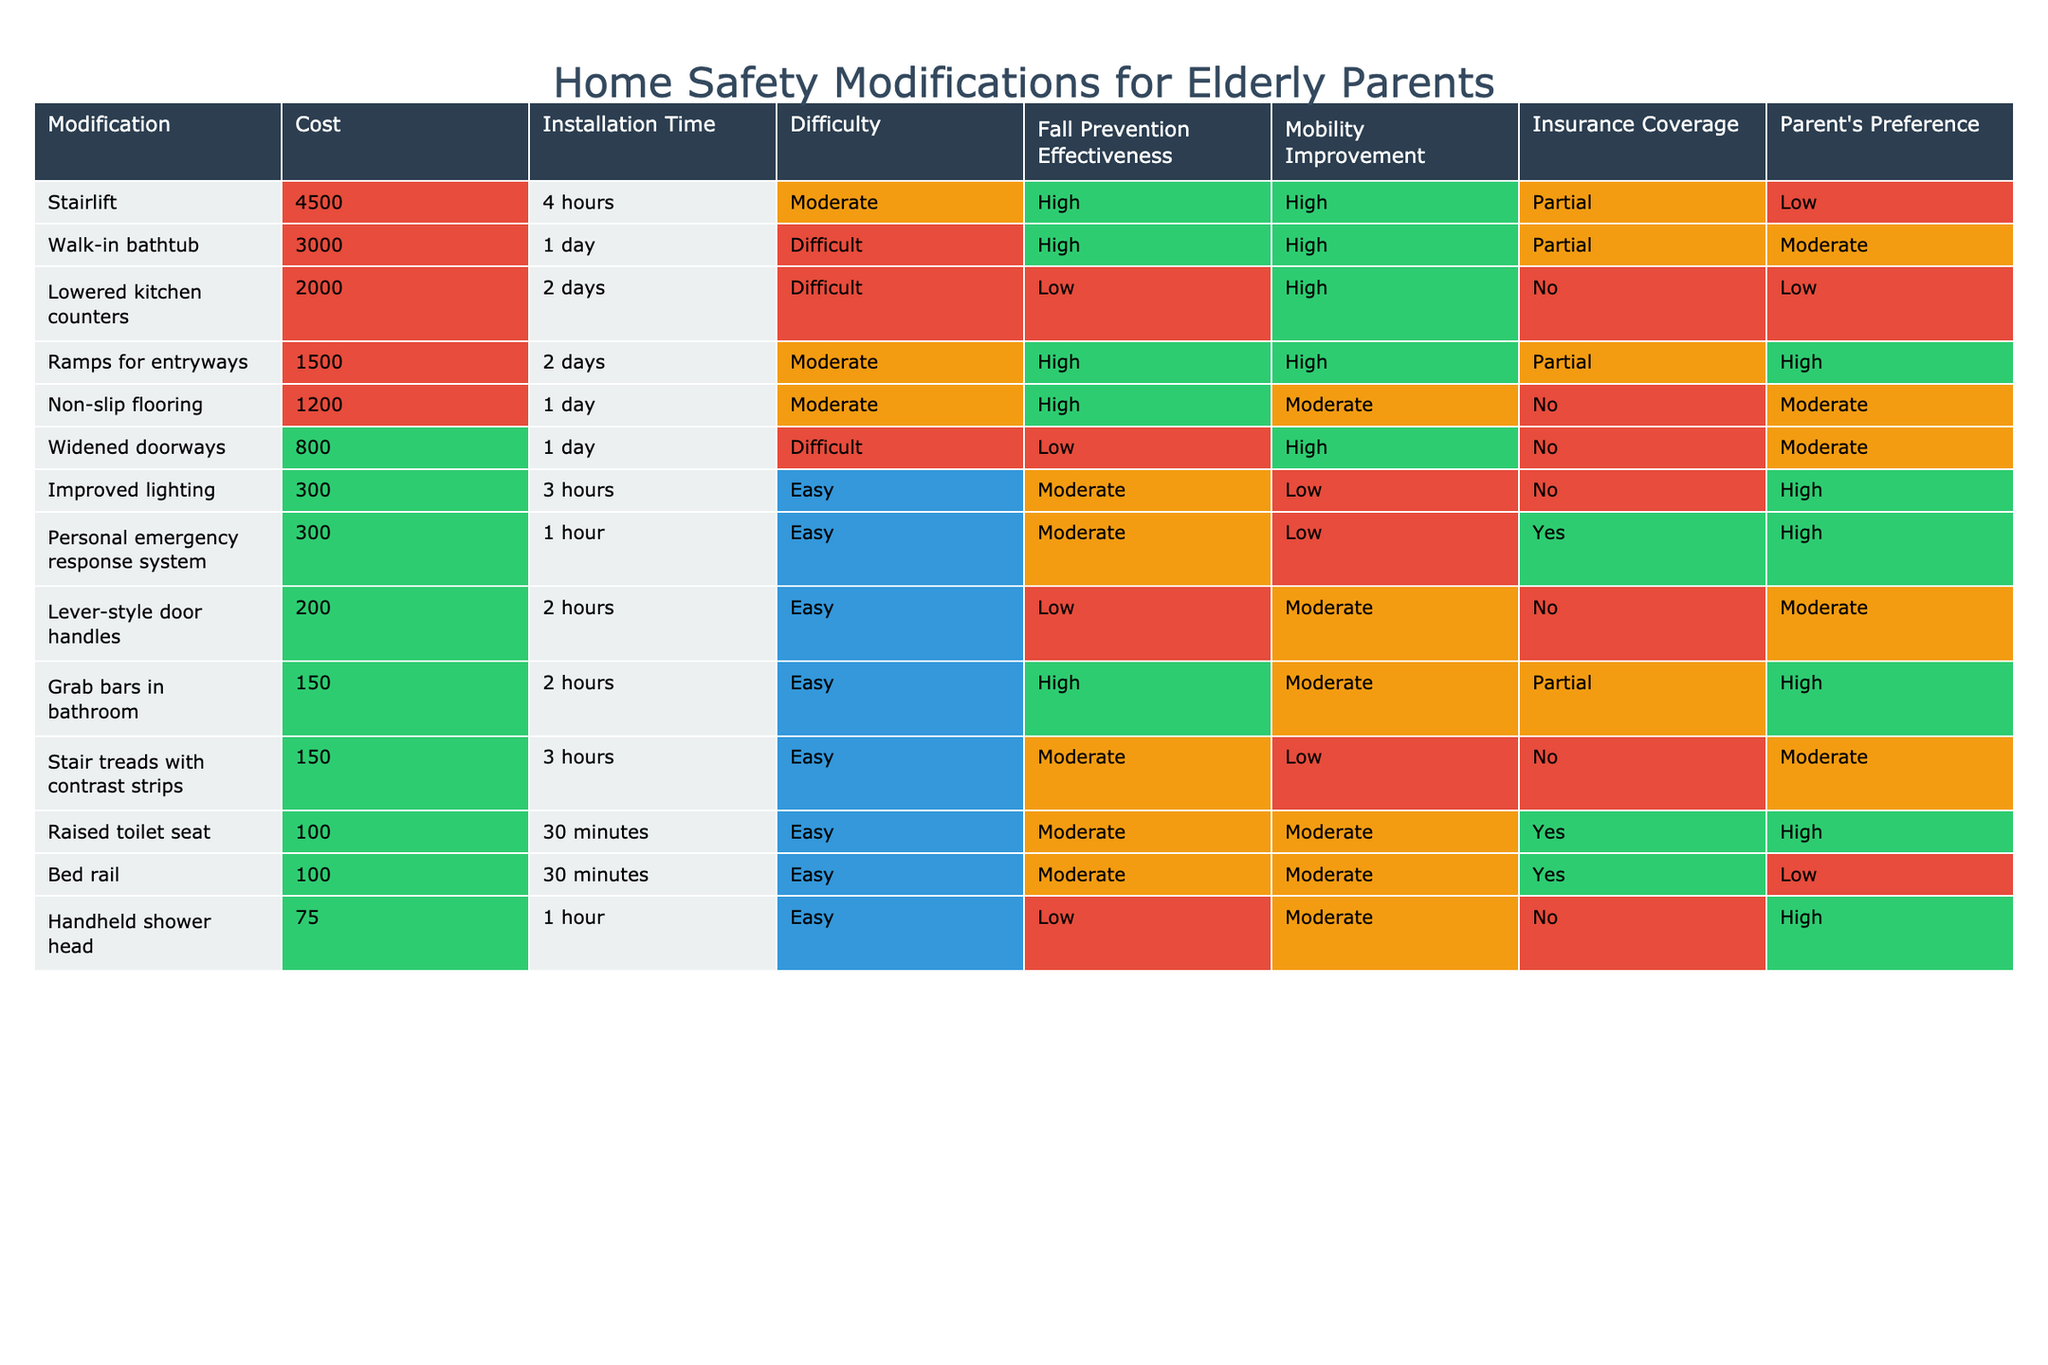What is the cost of installing grab bars in the bathroom? The table shows that the cost for installing grab bars in the bathroom is listed as 150.
Answer: 150 Which modification has the highest fall prevention effectiveness? The highest fall prevention effectiveness, marked as High, is observed in the following modifications: grab bars in the bathroom, walk-in bathtub, stairlift, non-slip flooring, ramps for entryways, and raised toilet seat.
Answer: Grab bars in bathroom, walk-in bathtub, stairlift, non-slip flooring, ramps for entryways, raised toilet seat How many modifications have insurance coverage listed as Yes? By checking the insurance coverage column, we can see that three modifications—raised toilet seat, personal emergency response system, and bed rail—are marked Yes.
Answer: 3 What is the average cost of all modifications with the effectiveness of fall prevention rated as High? The modifications with high fall prevention effectiveness are grab bars in the bathroom (150), walk-in bathtub (3000), stairlift (4500), non-slip flooring (1200), and ramps for entryways (1500). Their total cost is 150 + 3000 + 4500 + 1200 + 1500 = 12650. There are 5 modifications, so the average cost is 12650 / 5 = 2530.
Answer: 2530 Is there a modification that is both easy to install and approved by the parent? The analysis of the table reveals that grab bars in the bathroom, improved lighting, raised toilet seat, handheld shower head, and lever-style door handles are easy to install. Out of these, grab bars in the bathroom, raised toilet seat, and handheld shower head are also preferred by the parent.
Answer: Yes, grab bars in the bathroom, raised toilet seat, and handheld shower head What is the cost difference between the most expensive and least expensive modifications? The most expensive modification is the stairlift at 4500, while the least expensive modification is the handheld shower head at 75. Thus, the cost difference is 4500 - 75 = 4425.
Answer: 4425 